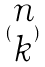<formula> <loc_0><loc_0><loc_500><loc_500>( \begin{matrix} n \\ k \end{matrix} )</formula> 